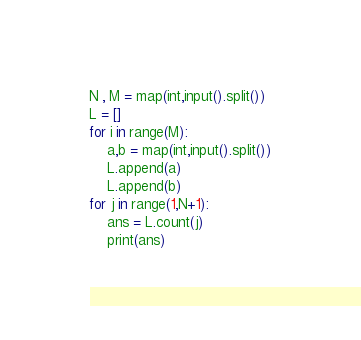<code> <loc_0><loc_0><loc_500><loc_500><_Python_>N , M = map(int,input().split())
L = []
for i in range(M):
    a,b = map(int,input().split())
    L.append(a)
    L.append(b)
for j in range(1,N+1):
    ans = L.count(j)
    print(ans)</code> 